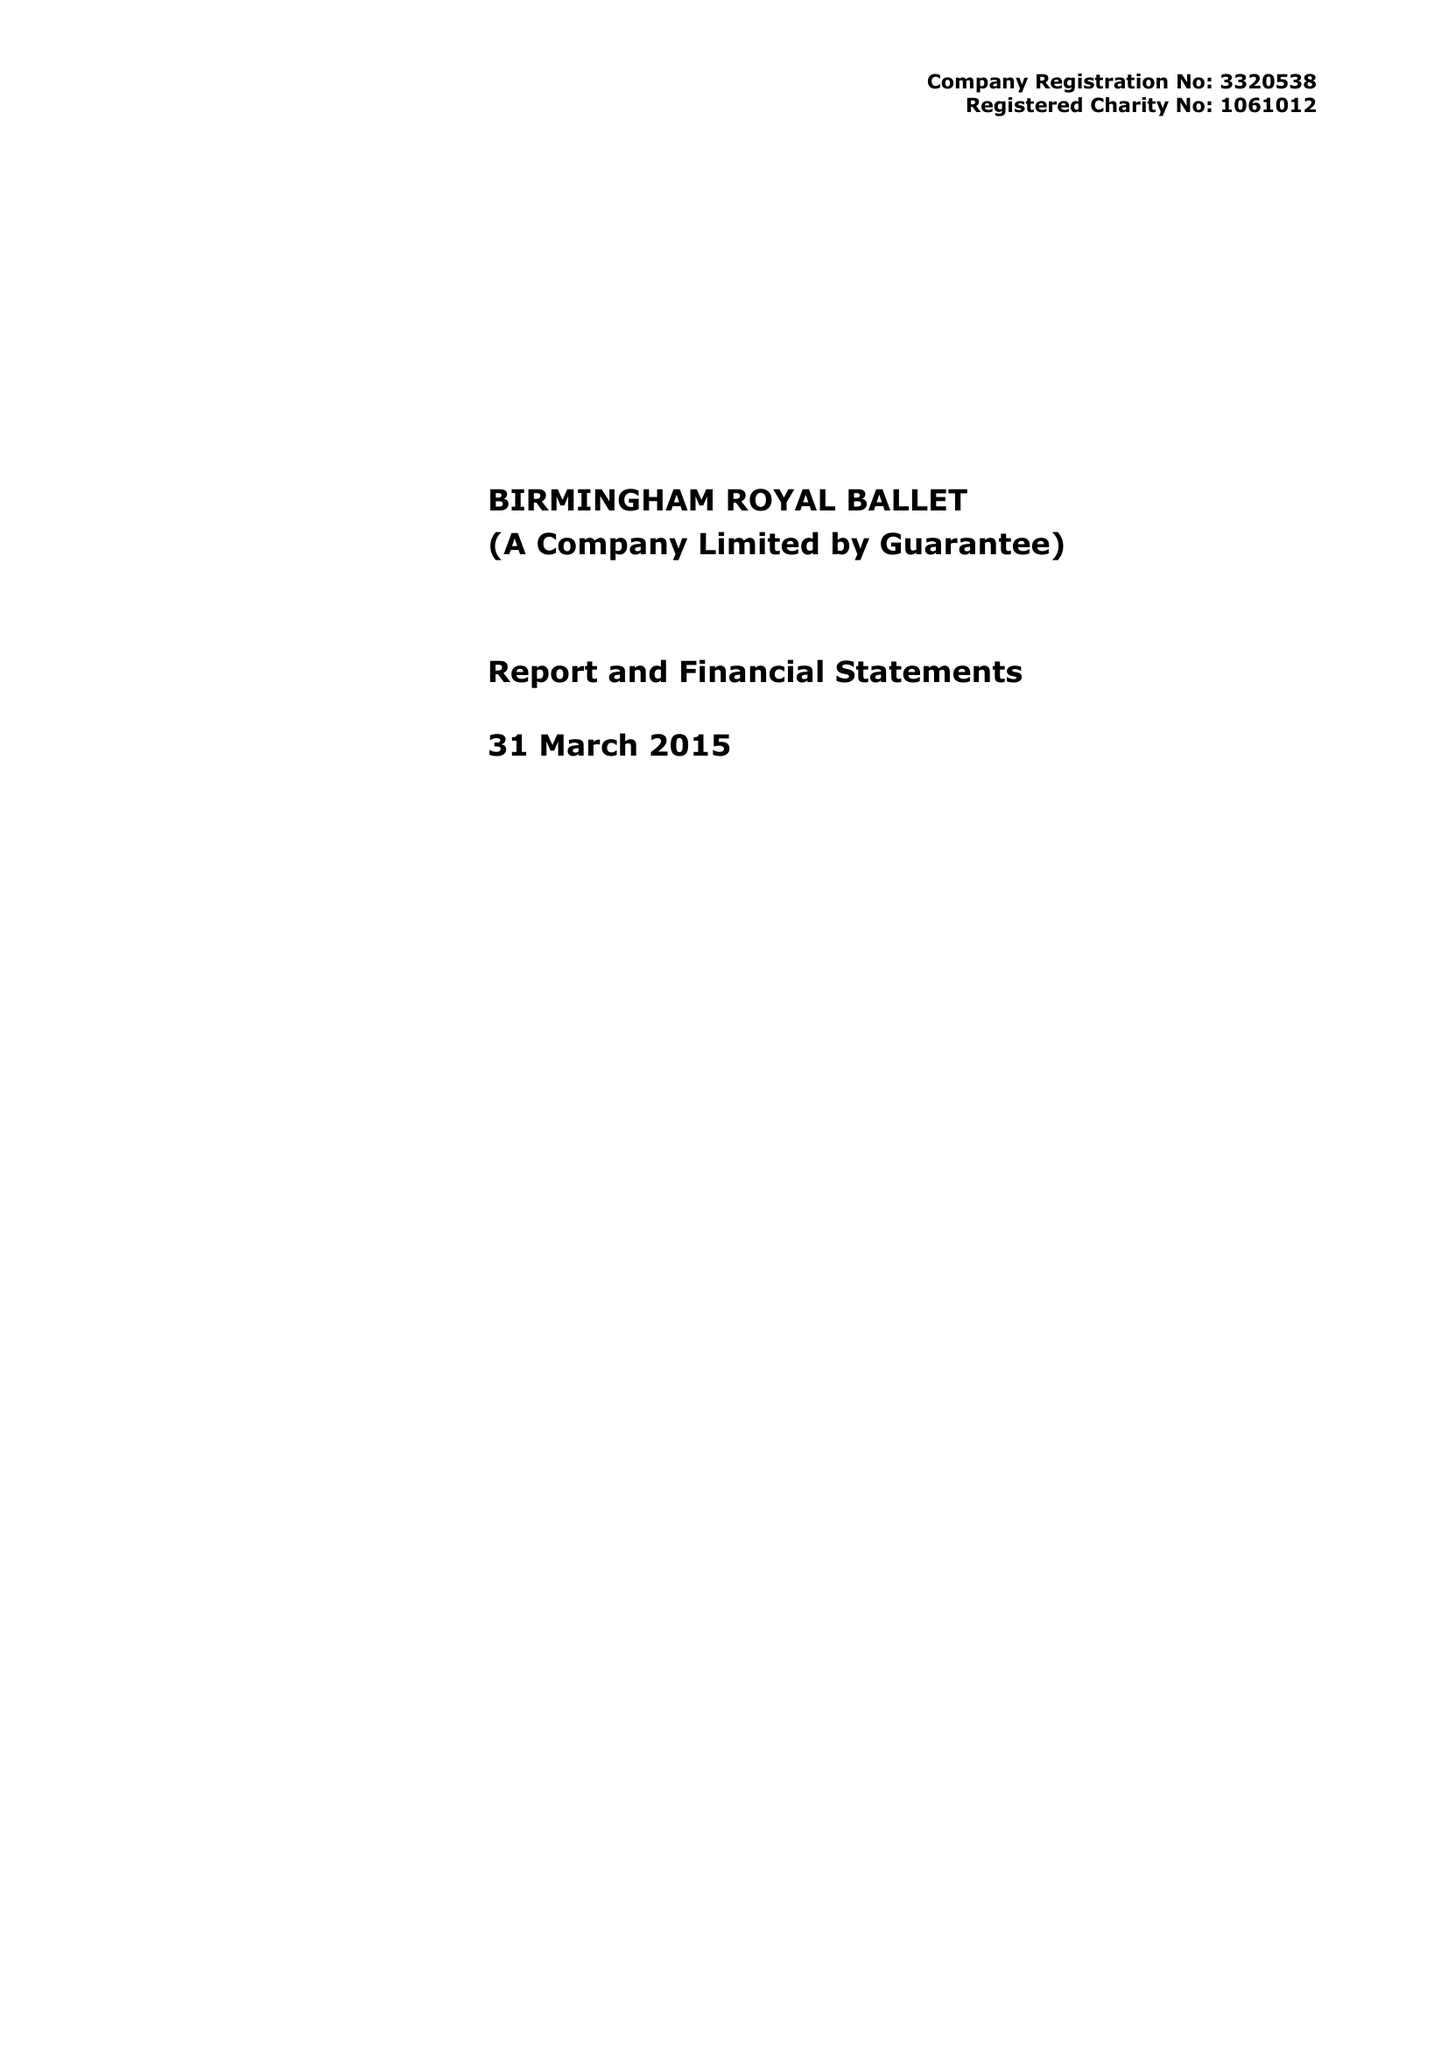What is the value for the spending_annually_in_british_pounds?
Answer the question using a single word or phrase. 12360293.00 